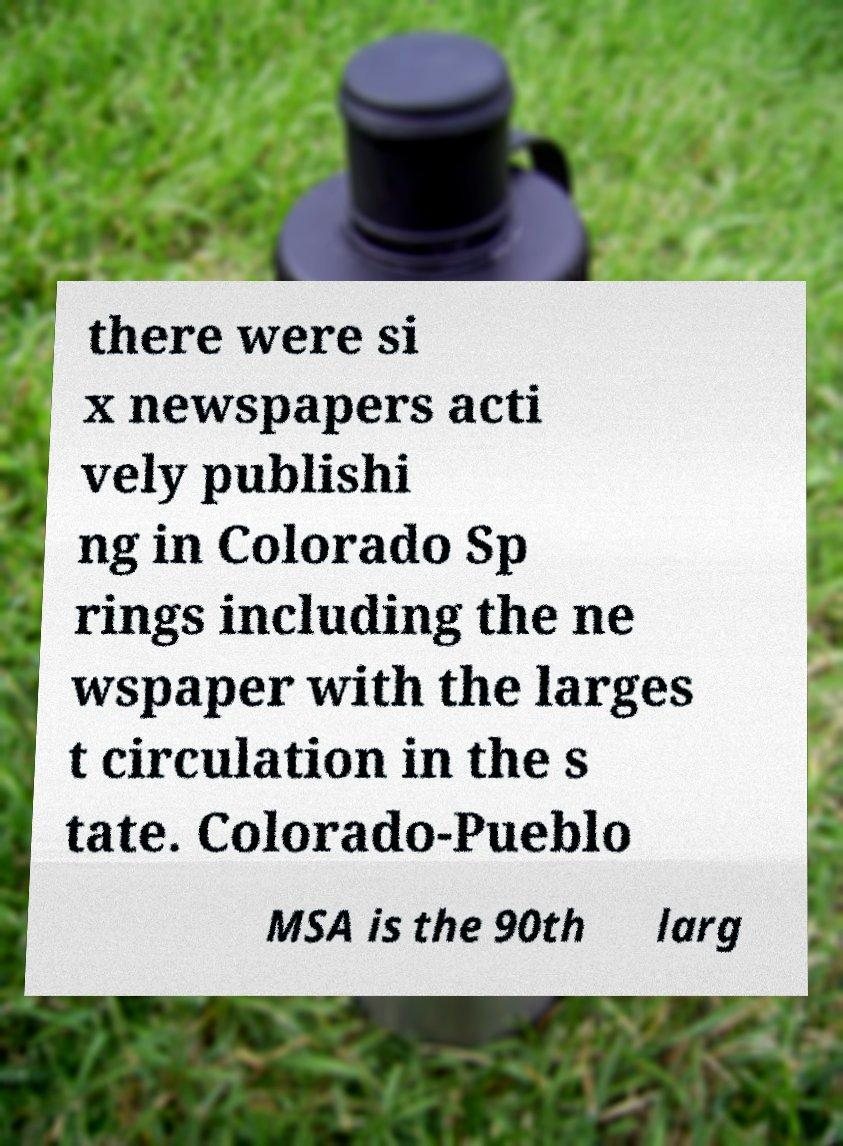Please identify and transcribe the text found in this image. there were si x newspapers acti vely publishi ng in Colorado Sp rings including the ne wspaper with the larges t circulation in the s tate. Colorado-Pueblo MSA is the 90th larg 